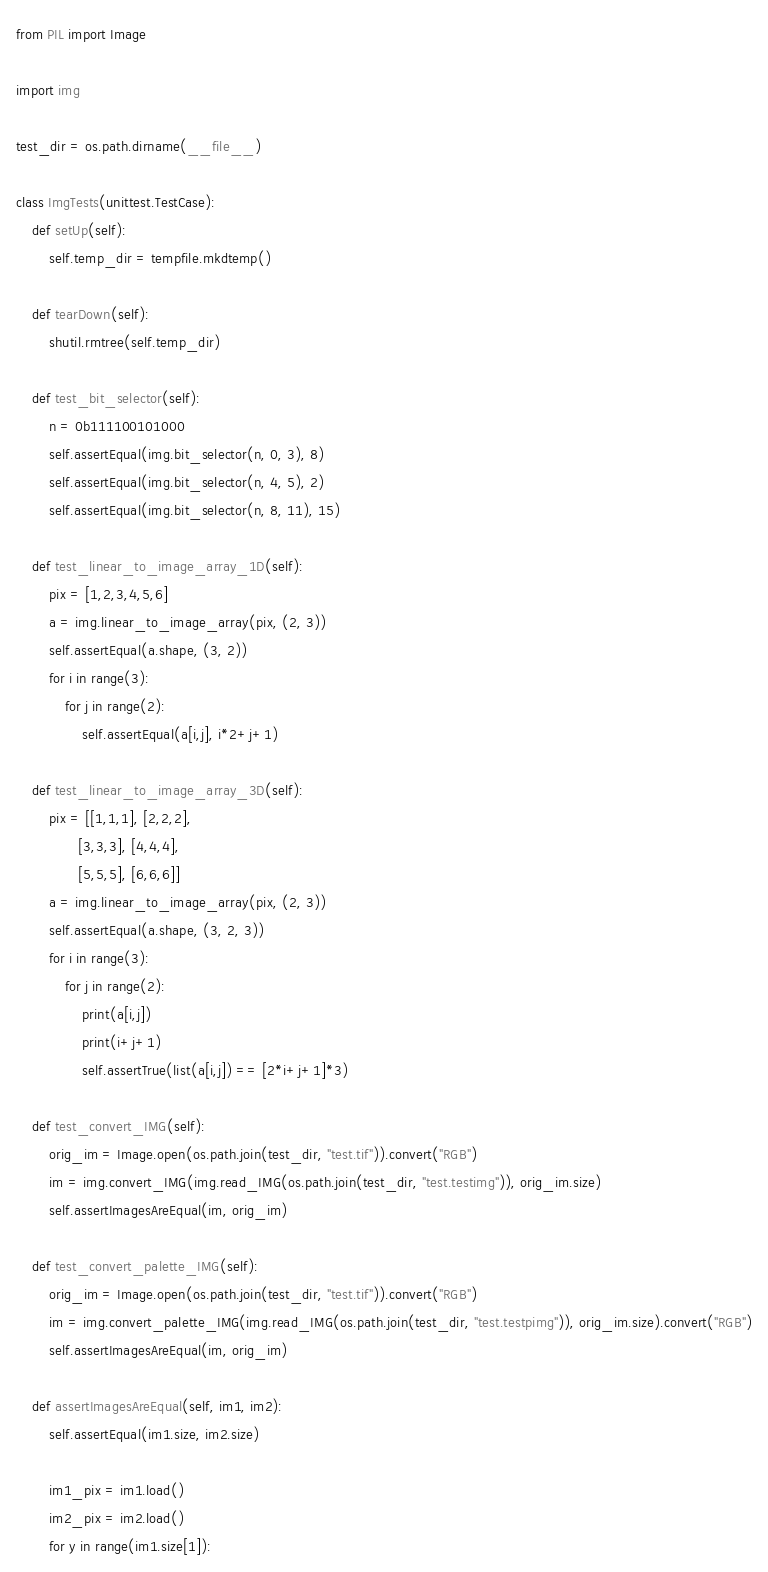Convert code to text. <code><loc_0><loc_0><loc_500><loc_500><_Python_>from PIL import Image

import img

test_dir = os.path.dirname(__file__)

class ImgTests(unittest.TestCase):
    def setUp(self):
        self.temp_dir = tempfile.mkdtemp()

    def tearDown(self):
        shutil.rmtree(self.temp_dir)

    def test_bit_selector(self):
        n = 0b111100101000
        self.assertEqual(img.bit_selector(n, 0, 3), 8)
        self.assertEqual(img.bit_selector(n, 4, 5), 2)
        self.assertEqual(img.bit_selector(n, 8, 11), 15)

    def test_linear_to_image_array_1D(self):
        pix = [1,2,3,4,5,6]
        a = img.linear_to_image_array(pix, (2, 3))
        self.assertEqual(a.shape, (3, 2))
        for i in range(3):
            for j in range(2):
                self.assertEqual(a[i,j], i*2+j+1)

    def test_linear_to_image_array_3D(self):
        pix = [[1,1,1], [2,2,2],
               [3,3,3], [4,4,4],
               [5,5,5], [6,6,6]]
        a = img.linear_to_image_array(pix, (2, 3))
        self.assertEqual(a.shape, (3, 2, 3))
        for i in range(3):
            for j in range(2):
                print(a[i,j])
                print(i+j+1)
                self.assertTrue(list(a[i,j]) == [2*i+j+1]*3)

    def test_convert_IMG(self):
        orig_im = Image.open(os.path.join(test_dir, "test.tif")).convert("RGB")
        im = img.convert_IMG(img.read_IMG(os.path.join(test_dir, "test.testimg")), orig_im.size)
        self.assertImagesAreEqual(im, orig_im)

    def test_convert_palette_IMG(self):
        orig_im = Image.open(os.path.join(test_dir, "test.tif")).convert("RGB")
        im = img.convert_palette_IMG(img.read_IMG(os.path.join(test_dir, "test.testpimg")), orig_im.size).convert("RGB")
        self.assertImagesAreEqual(im, orig_im)

    def assertImagesAreEqual(self, im1, im2):
        self.assertEqual(im1.size, im2.size)

        im1_pix = im1.load()
        im2_pix = im2.load()
        for y in range(im1.size[1]):</code> 